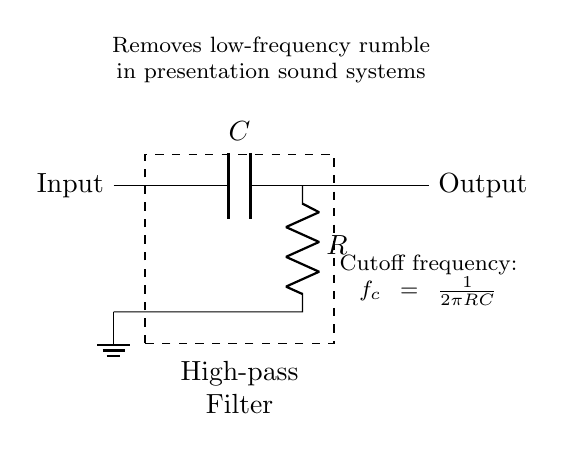What type of filter is depicted in the circuit? The circuit is a high-pass filter because it allows high frequencies to pass while attenuating low frequencies. This is indicated by the placement of the capacitor in series with the resistor, which is a common configuration for high-pass filtering.
Answer: High-pass filter What components are present in the circuit? The circuit contains a capacitor and a resistor, both of which are labeled as C and R, respectively. Their arrangement and function in the circuit confirm their roles in filtering.
Answer: Capacitor and resistor What does the dashed box represent? The dashed box surrounds the combination of the capacitor and resistor, indicating that they form a single unit, the high-pass filter. This visual cue emphasizes that all components inside collectively perform the filtering function.
Answer: High-pass filter What is the cutoff frequency formula shown in the diagram? The cutoff frequency formula is given as f_c = 1/(2πRC). This formula is essential for determining the frequency at which the filter begins to pass signals effectively and is derived from the properties of the capacitor-resistor combination.
Answer: f_c = 1/(2πRC) What happens to low frequencies when using this filter? Low frequencies are attenuated or reduced significantly by the filter. The design of a high-pass filter inherently blocks low-frequency signals while allowing higher frequencies to pass through, providing clarity in sound systems during presentations.
Answer: Attenuated What is the role of the capacitor in this circuit? The capacitor blocks low-frequency signals while allowing high-frequency signals to pass, which is crucial in filtering applications. Its reactance decreases with increasing frequency, enabling high frequencies to be transmitted to the output effectively.
Answer: Blocks low frequencies 